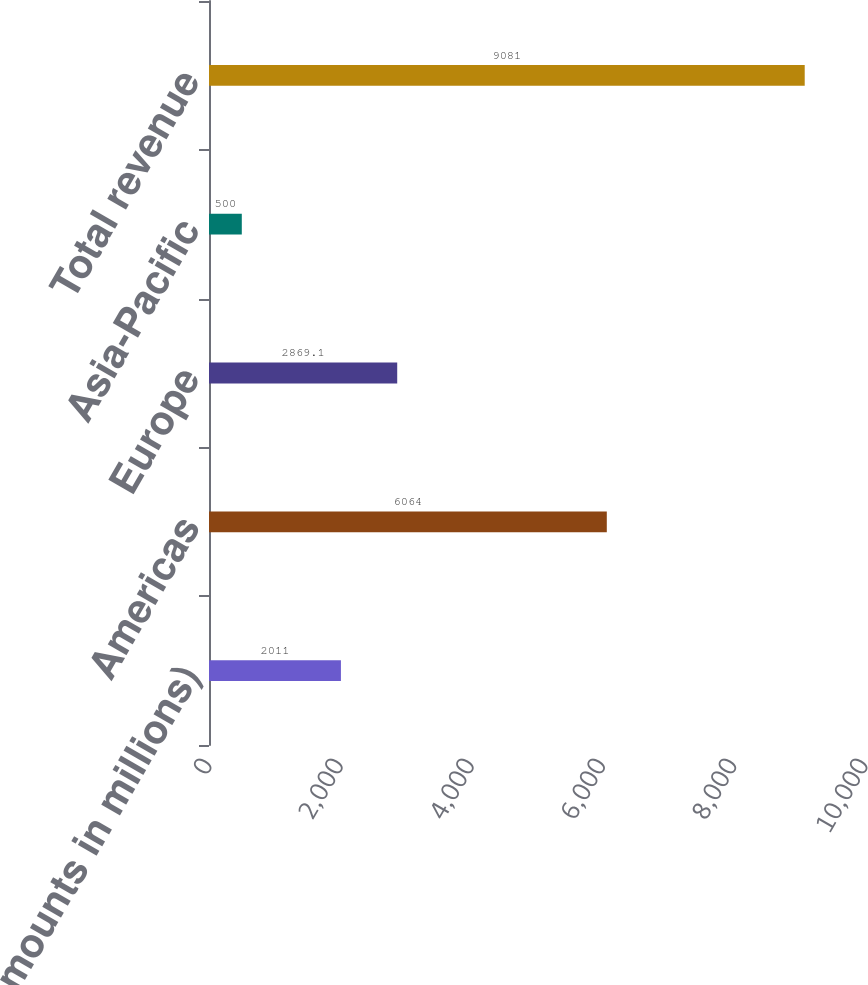Convert chart. <chart><loc_0><loc_0><loc_500><loc_500><bar_chart><fcel>(Dollar amounts in millions)<fcel>Americas<fcel>Europe<fcel>Asia-Pacific<fcel>Total revenue<nl><fcel>2011<fcel>6064<fcel>2869.1<fcel>500<fcel>9081<nl></chart> 